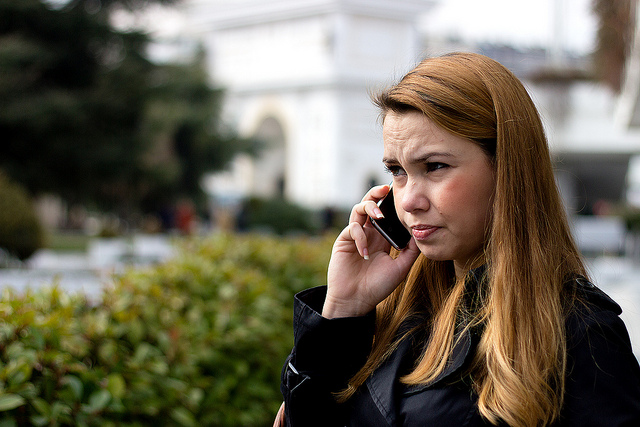<image>Is this person being berated over the phone? It is ambiguous whether this person is being berated over the phone. It can be both yes and no. Is this person being berated over the phone? I don't know if this person is being berated over the phone. It can be both yes or no. 